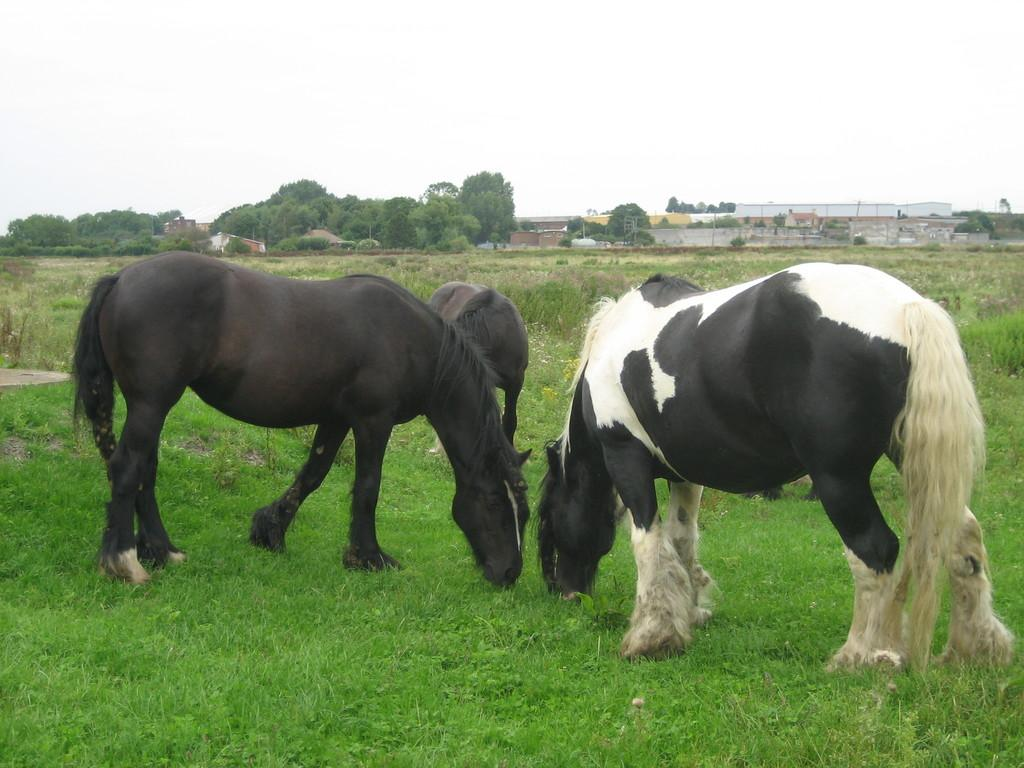What animals are in the foreground of the image? There are three horses in the foreground of the image. What can be seen in the background of the image? There are trees and buildings in the background of the image. What type of terrain is visible at the bottom of the image? Grass is present at the bottom of the image. What is visible at the top of the image? The sky is visible at the top of the image. What type of spoon can be seen in the image? There is no spoon present in the image. How does the acoustics of the image affect the sound of the horses' hooves? The image does not provide any information about the acoustics, so it is impossible to determine how it might affect the sound of the horses' hooves. 